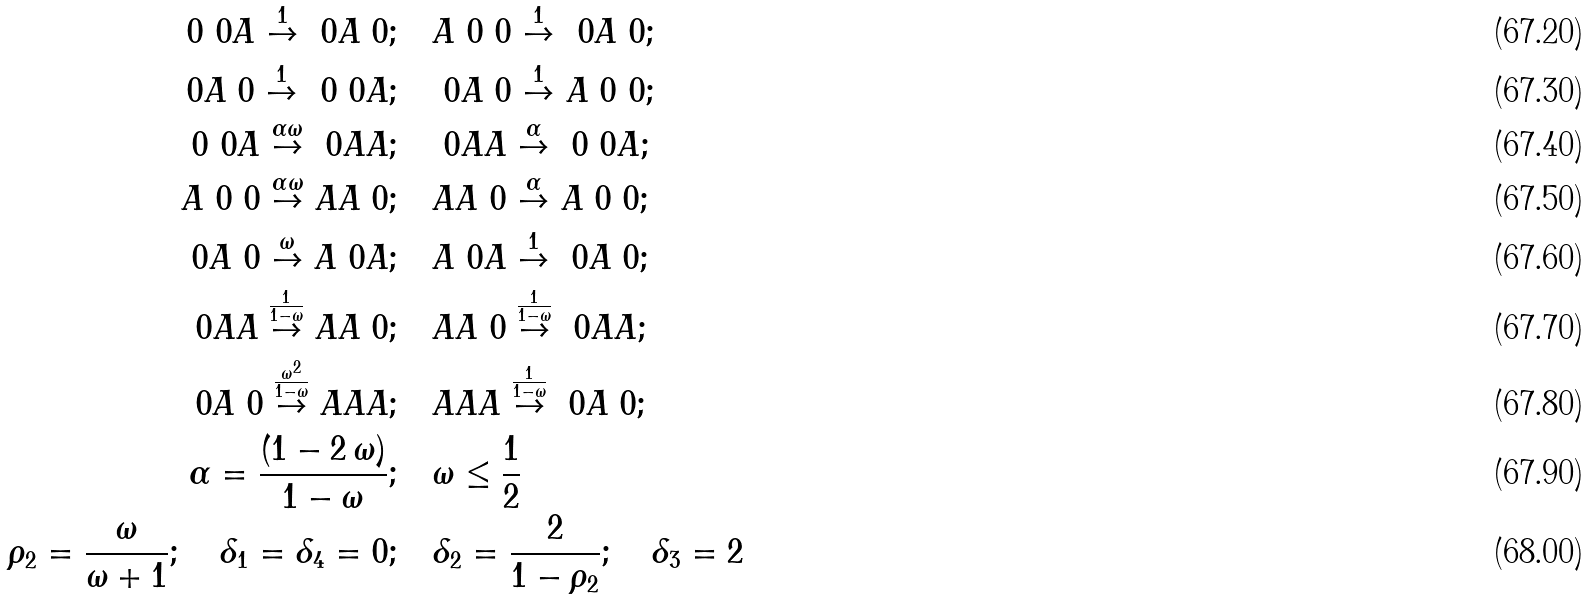<formula> <loc_0><loc_0><loc_500><loc_500>\ 0 \ 0 A \overset { 1 } { \to } \ 0 A \ 0 ; & \quad A \ 0 \ 0 \overset { 1 } { \to } \ 0 A \ 0 ; \\ \ 0 A \ 0 \overset { 1 } { \to } \ 0 \ 0 A ; & \quad \ 0 A \ 0 \overset { 1 } { \to } A \ 0 \ 0 ; \\ \ 0 \ 0 A \overset { \alpha \omega } { \to } \ 0 A A ; & \quad \ 0 A A \overset { \alpha } { \to } \ 0 \ 0 A ; \\ A \ 0 \ 0 \overset { \alpha \omega } { \to } A A \ 0 ; & \quad A A \ 0 \overset { \alpha } { \to } A \ 0 \ 0 ; \\ \ 0 A \ 0 \overset { \omega } { \to } A \ 0 A ; & \quad A \ 0 A \overset { 1 } { \to } \ 0 A \ 0 ; \\ \ 0 A A \overset { \frac { 1 } { 1 - \omega } } { \to } A A \ 0 ; & \quad A A \ 0 \overset { \frac { 1 } { 1 - \omega } } { \to } \ 0 A A ; \\ \ 0 A \ 0 \overset { \frac { \omega ^ { 2 } } { 1 - \omega } } { \to } A A A ; & \quad A A A \overset { \frac { 1 } { 1 - \omega } } { \to } \ 0 A \ 0 ; \\ \alpha = \frac { ( 1 - 2 \, \omega ) } { 1 - \omega } ; & \quad \omega \leq \frac { 1 } { 2 } \\ \rho _ { 2 } = \frac { \omega } { \omega + 1 } ; \quad \delta _ { 1 } = \delta _ { 4 } = 0 ; & \quad \delta _ { 2 } = \frac { 2 } { 1 - \rho _ { 2 } } ; \quad \delta _ { 3 } = 2</formula> 